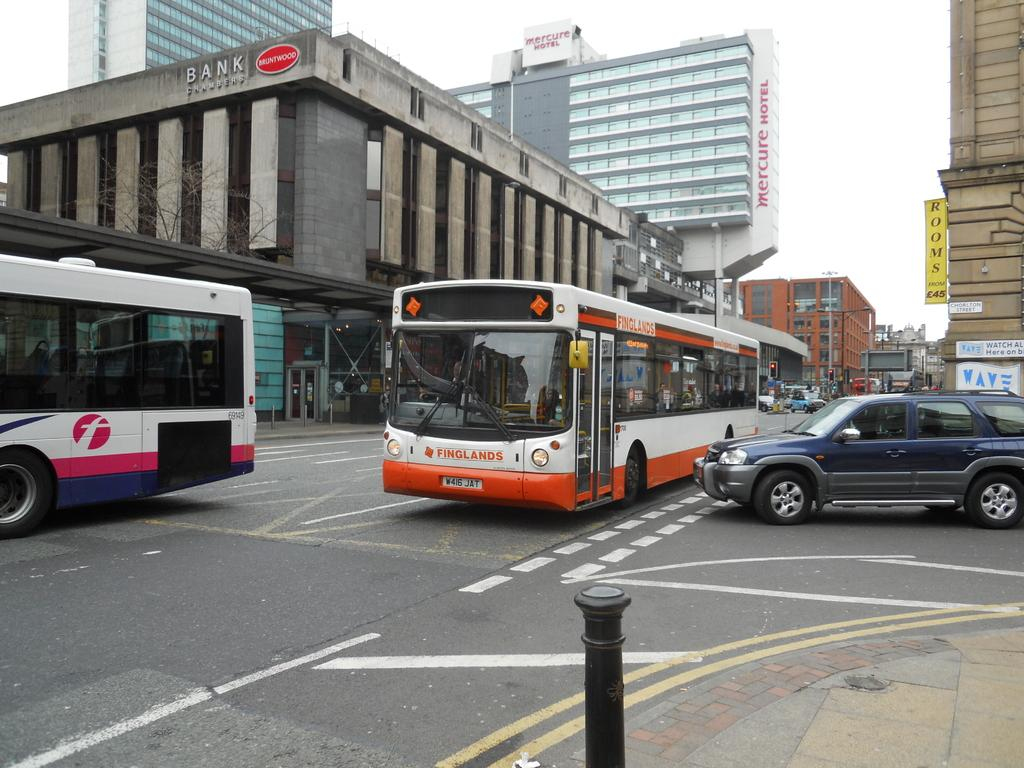What type of view is shown in the image? The image is an outside view. How many buses can be seen in the image? There are two buses in the image. What other vehicles are present on the road in the image? There are cars on the road in the image. What can be seen in the background of the image? There are buildings in the background of the image. What is visible at the top of the image? The sky is visible at the top of the image. How many ladybugs are crawling on the buses in the image? There are no ladybugs present in the image; it only shows buses, cars, buildings, and the sky. What type of legal advice is the lawyer providing in the image? There is no lawyer present in the image, so it is not possible to determine the type of legal advice being provided. 